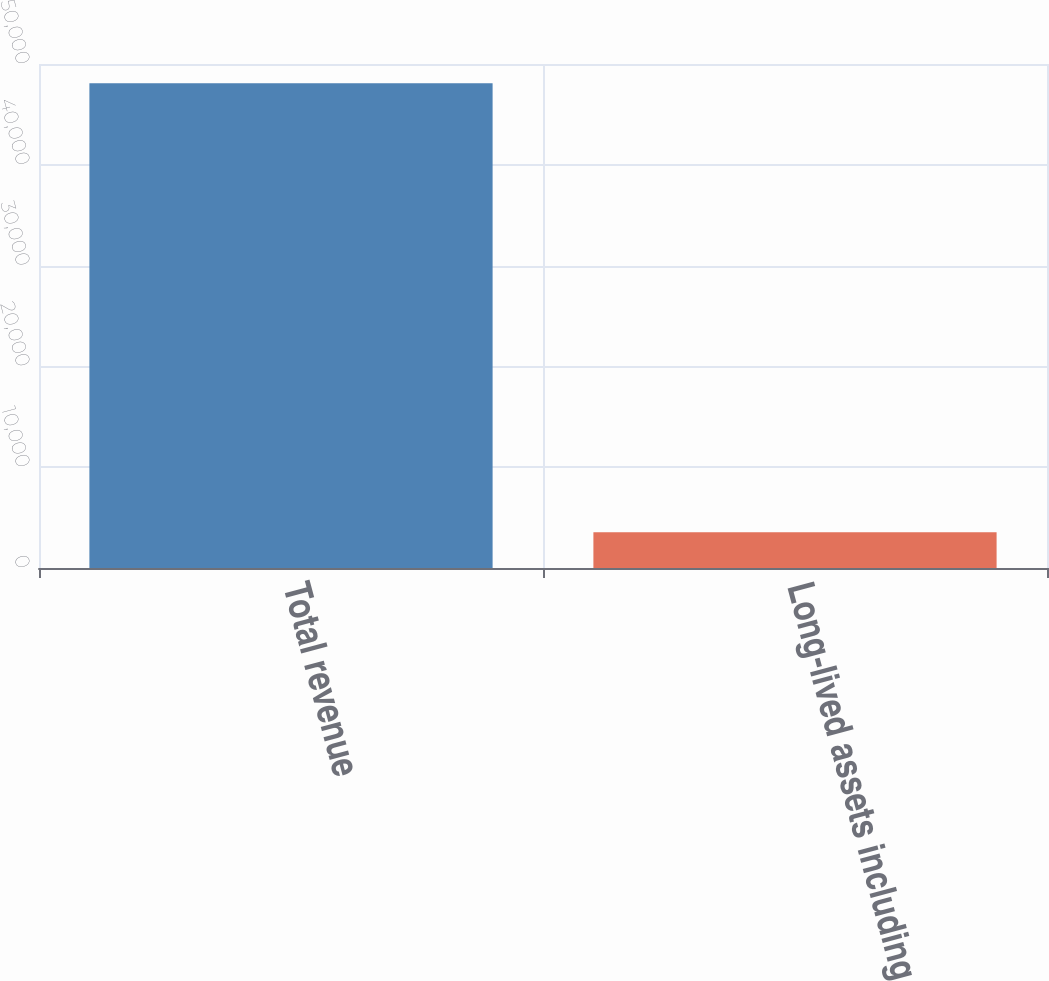<chart> <loc_0><loc_0><loc_500><loc_500><bar_chart><fcel>Total revenue<fcel>Long-lived assets including<nl><fcel>48087<fcel>3546<nl></chart> 